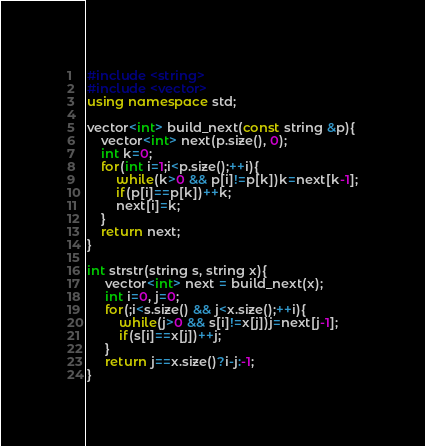Convert code to text. <code><loc_0><loc_0><loc_500><loc_500><_C++_>#include <string>
#include <vector>
using namespace std;

vector<int> build_next(const string &p){
    vector<int> next(p.size(), 0);
    int k=0;
    for(int i=1;i<p.size();++i){
        while(k>0 && p[i]!=p[k])k=next[k-1];
        if(p[i]==p[k])++k;
        next[i]=k;
    }
    return next;
}

int strstr(string s, string x){
     vector<int> next = build_next(x);
     int i=0, j=0;
     for(;i<s.size() && j<x.size();++i){
         while(j>0 && s[i]!=x[j])j=next[j-1];
         if(s[i]==x[j])++j;
     }
     return j==x.size()?i-j:-1;
}</code> 